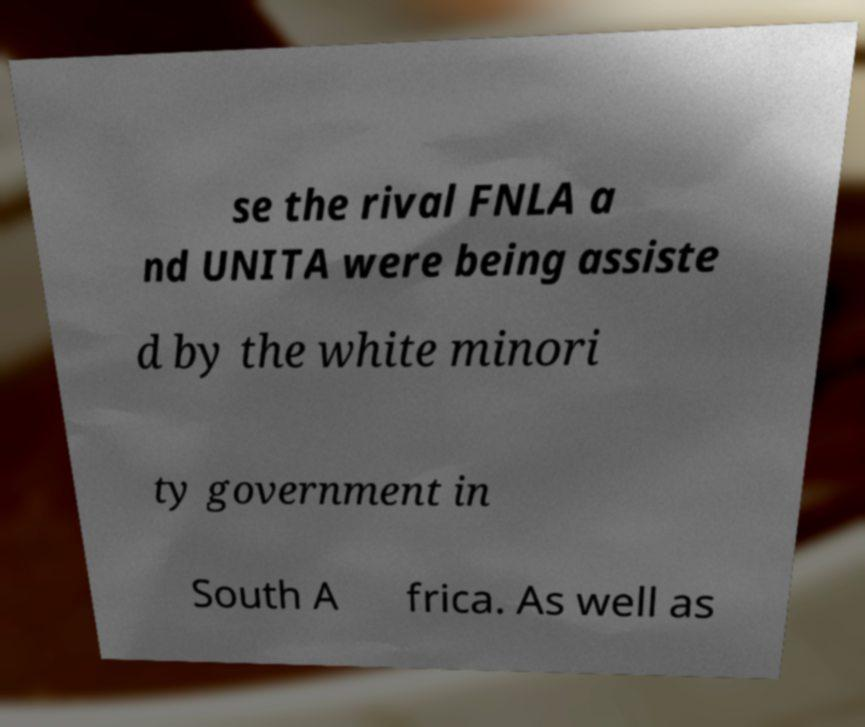What messages or text are displayed in this image? I need them in a readable, typed format. se the rival FNLA a nd UNITA were being assiste d by the white minori ty government in South A frica. As well as 